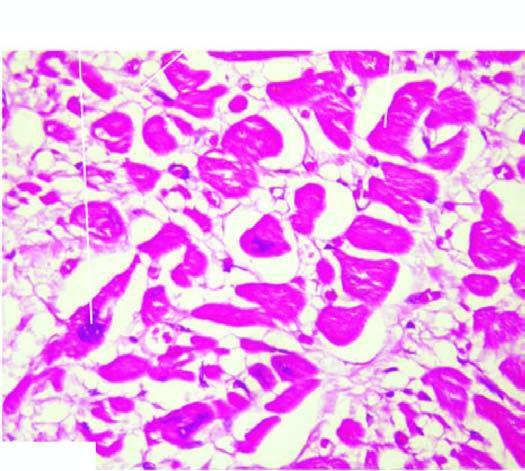re the tubular epithelial cells thick with prominent vesicular nuclei?
Answer the question using a single word or phrase. No 